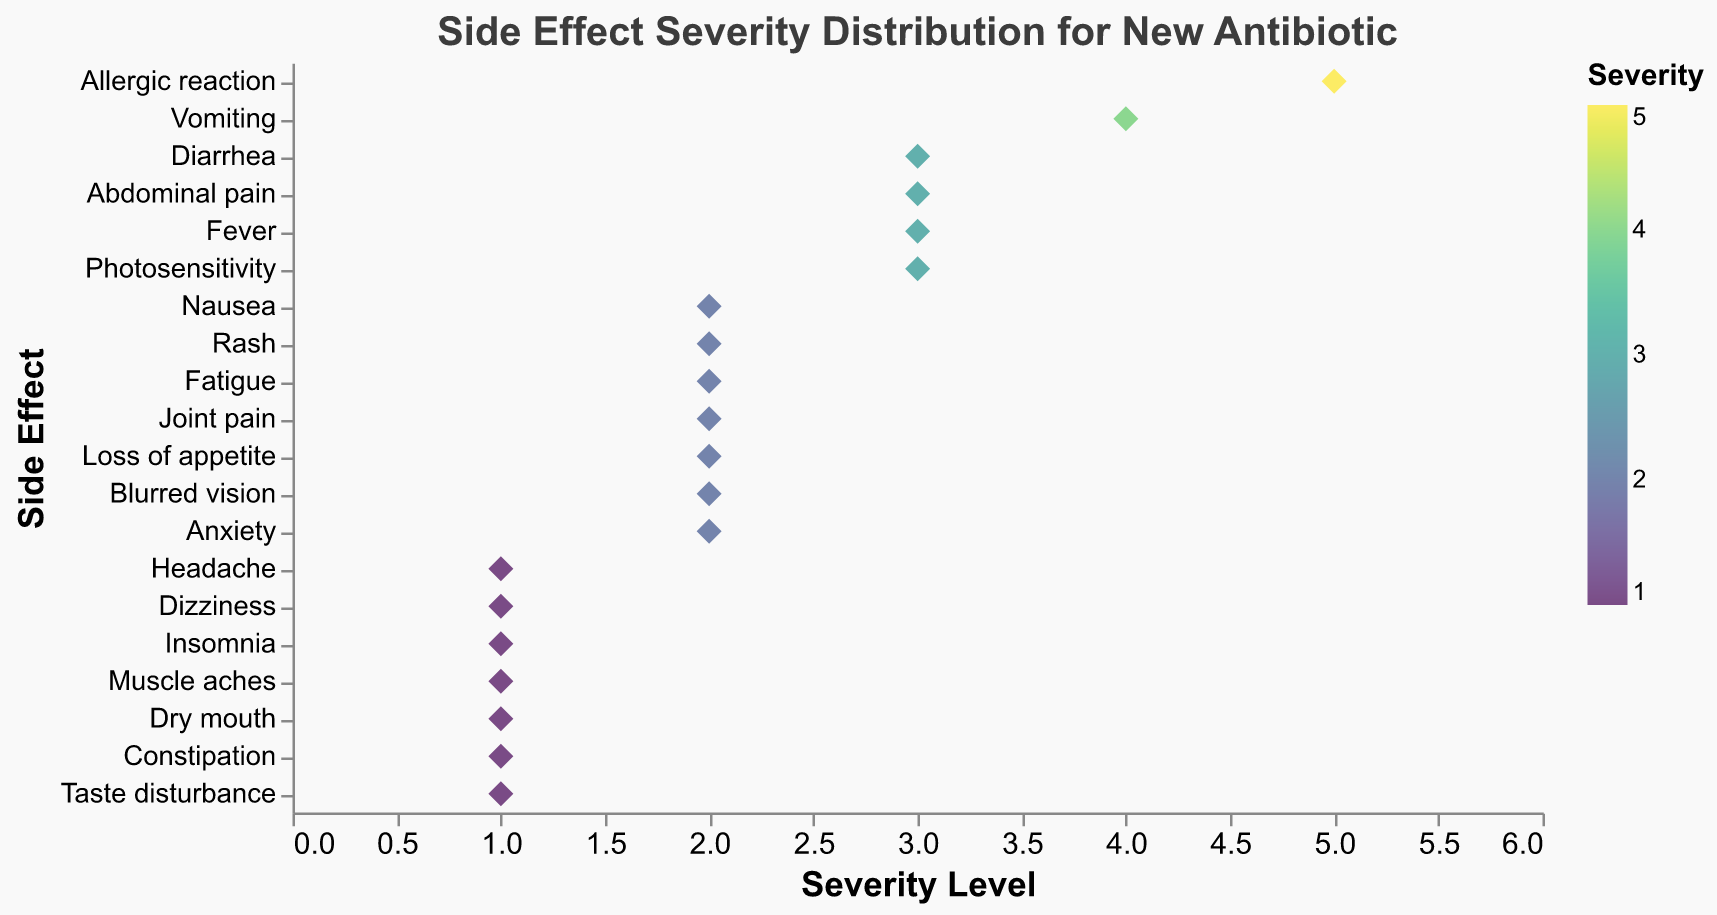What is the title of the strip plot? The title of the strip plot is typically located at the top of the figure and is written in a larger font to be easily noticeable. In this case, the title reads "Side Effect Severity Distribution for New Antibiotic."
Answer: Side Effect Severity Distribution for New Antibiotic What is the range of the severity levels displayed on the x-axis? The x-axis, representing the severity levels, ranges from 0 to 6. This can be identified by observing the numeric ticks and labels along the x-axis.
Answer: 0 to 6 How many side effects have a severity level of 1? By analyzing the points on the strip plot located at the x-value of 1 on the severity axis, we can count the number of side effects. There are six side effects with a severity level of 1.
Answer: 6 Which side effect has the highest severity level, and what is that level? The strip plot shows varying severity levels for different side effects along the x-axis. The side effect with the highest severity is "Allergic reaction," with a severity level of 5.
Answer: Allergic reaction, 5 What are the side effects with a severity level of 3? Observing the points on the strip plot where the severity level is 3, the side effects listed are "Diarrhea," "Abdominal pain," "Fever," and "Photosensitivity."
Answer: Diarrhea, Abdominal pain, Fever, Photosensitivity How many side effects fall within the severity range of 1 to 2 inclusive? To find this, count all the side effects that have a severity level of either 1 or 2. The side effects are "Headache," "Dizziness," "Insomnia," "Muscle aches," "Dry mouth," "Constipation," "Nausea," "Rash," "Fatigue," "Joint pain," "Loss of appetite," "Blurred vision," "Anxiety," "Taste disturbance," totaling 14.
Answer: 14 Compare the severity of "Vomiting" and "Fatigue." Which one is more severe? The severity of "Vomiting" is 4, while the severity of "Fatigue" is 2. By comparing these values, one can see that "Vomiting" is more severe than "Fatigue."
Answer: Vomiting What is the average severity level of the side effects listed? Calculate the total sum of the severity levels for all side effects and divide by the number of side effects. The sum is (2 + 3 + 1 + 2 + 1 + 2 + 1 + 3 + 4 + 5 + 2 + 1 + 2 + 3 + 1 + 2 + 1 + 2 + 3 + 1) = 46. There are 20 side effects in total. Therefore, the average severity is 46 / 20 = 2.3.
Answer: 2.3 Which side effect has a severity level near the middle of the range, and what is that level? The middle of the range, considering 0 to 6, is 3. Observing the strip plot, we can see the side effects with severity level 3 are "Diarrhea," "Abdominal pain," "Fever," and "Photosensitivity." Any of these could be considered near the middle.
Answer: Diarrhea, Abdominal pain, Fever, Photosensitivity What color is used to represent a severity level of 5 on the plot? The color scale based on severity levels uses the "viridis" scheme. Observing the legend, the highest severity level (5) is represented by a distinct color, which is a shade of yellow-green.
Answer: Yellow-green 